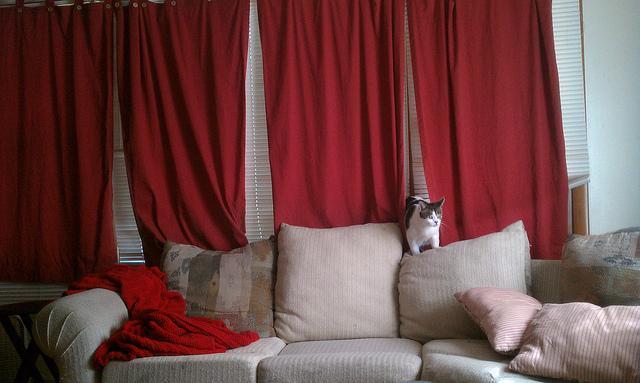How many pillows are on the couch?
Give a very brief answer. 5. How many men are doing tricks on their skateboard?
Give a very brief answer. 0. 